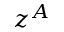<formula> <loc_0><loc_0><loc_500><loc_500>z ^ { A }</formula> 